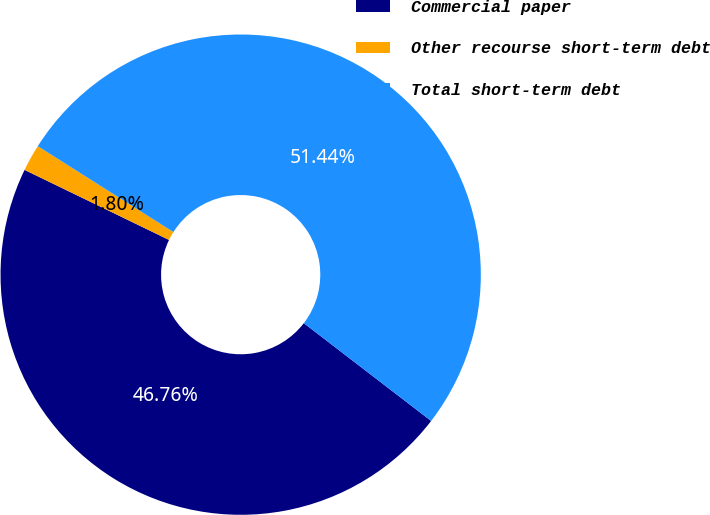<chart> <loc_0><loc_0><loc_500><loc_500><pie_chart><fcel>Commercial paper<fcel>Other recourse short-term debt<fcel>Total short-term debt<nl><fcel>46.76%<fcel>1.8%<fcel>51.44%<nl></chart> 